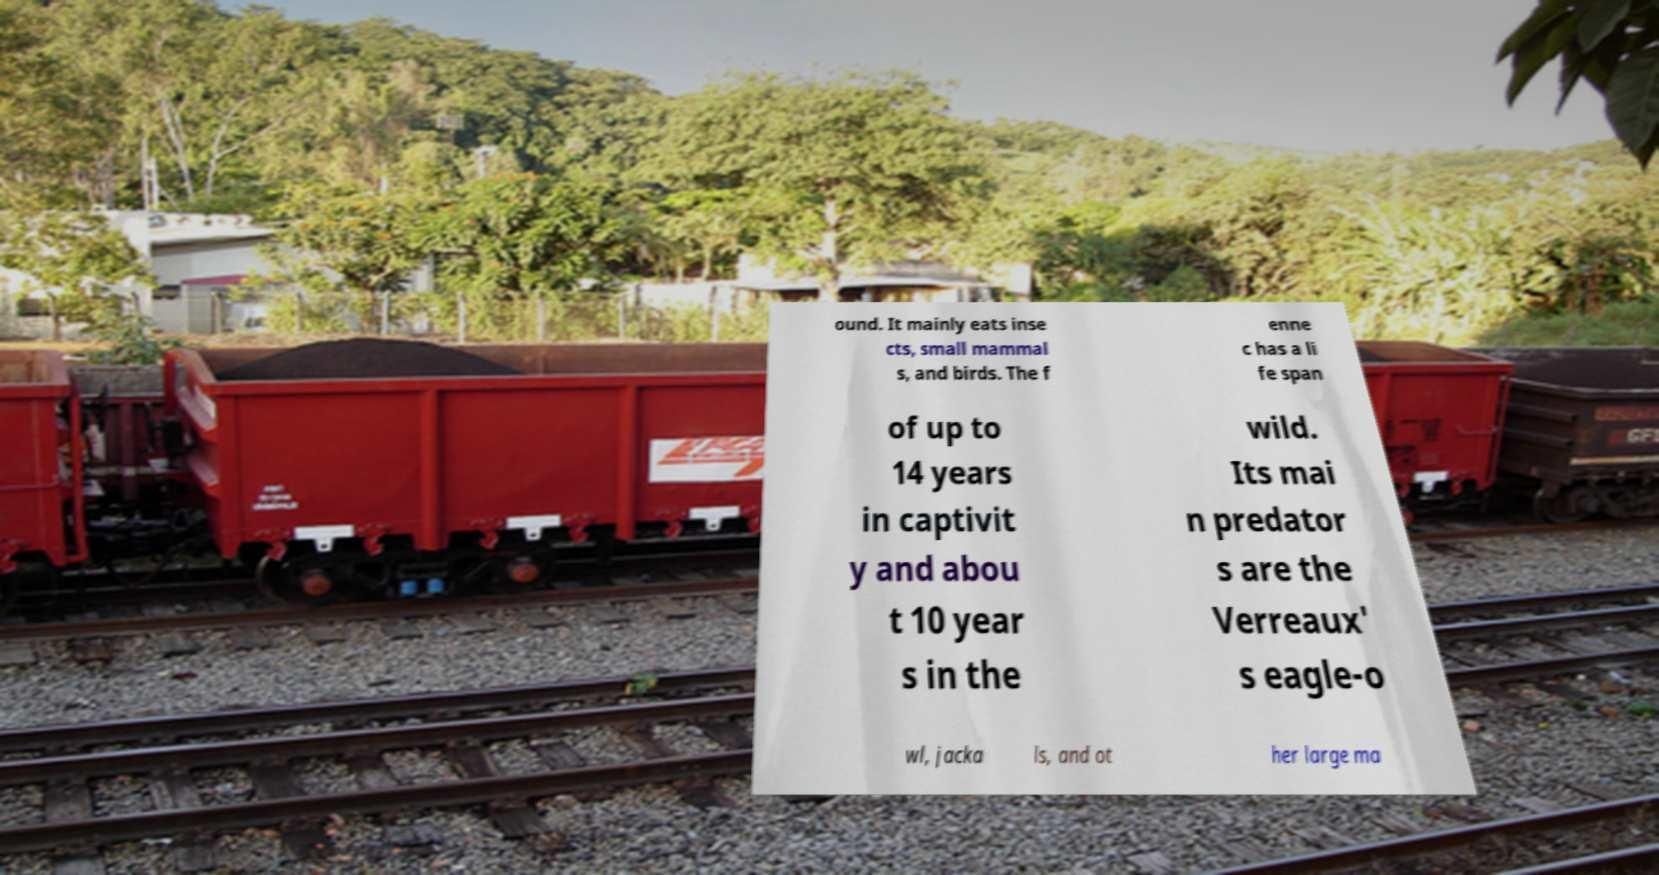Please identify and transcribe the text found in this image. ound. It mainly eats inse cts, small mammal s, and birds. The f enne c has a li fe span of up to 14 years in captivit y and abou t 10 year s in the wild. Its mai n predator s are the Verreaux' s eagle-o wl, jacka ls, and ot her large ma 